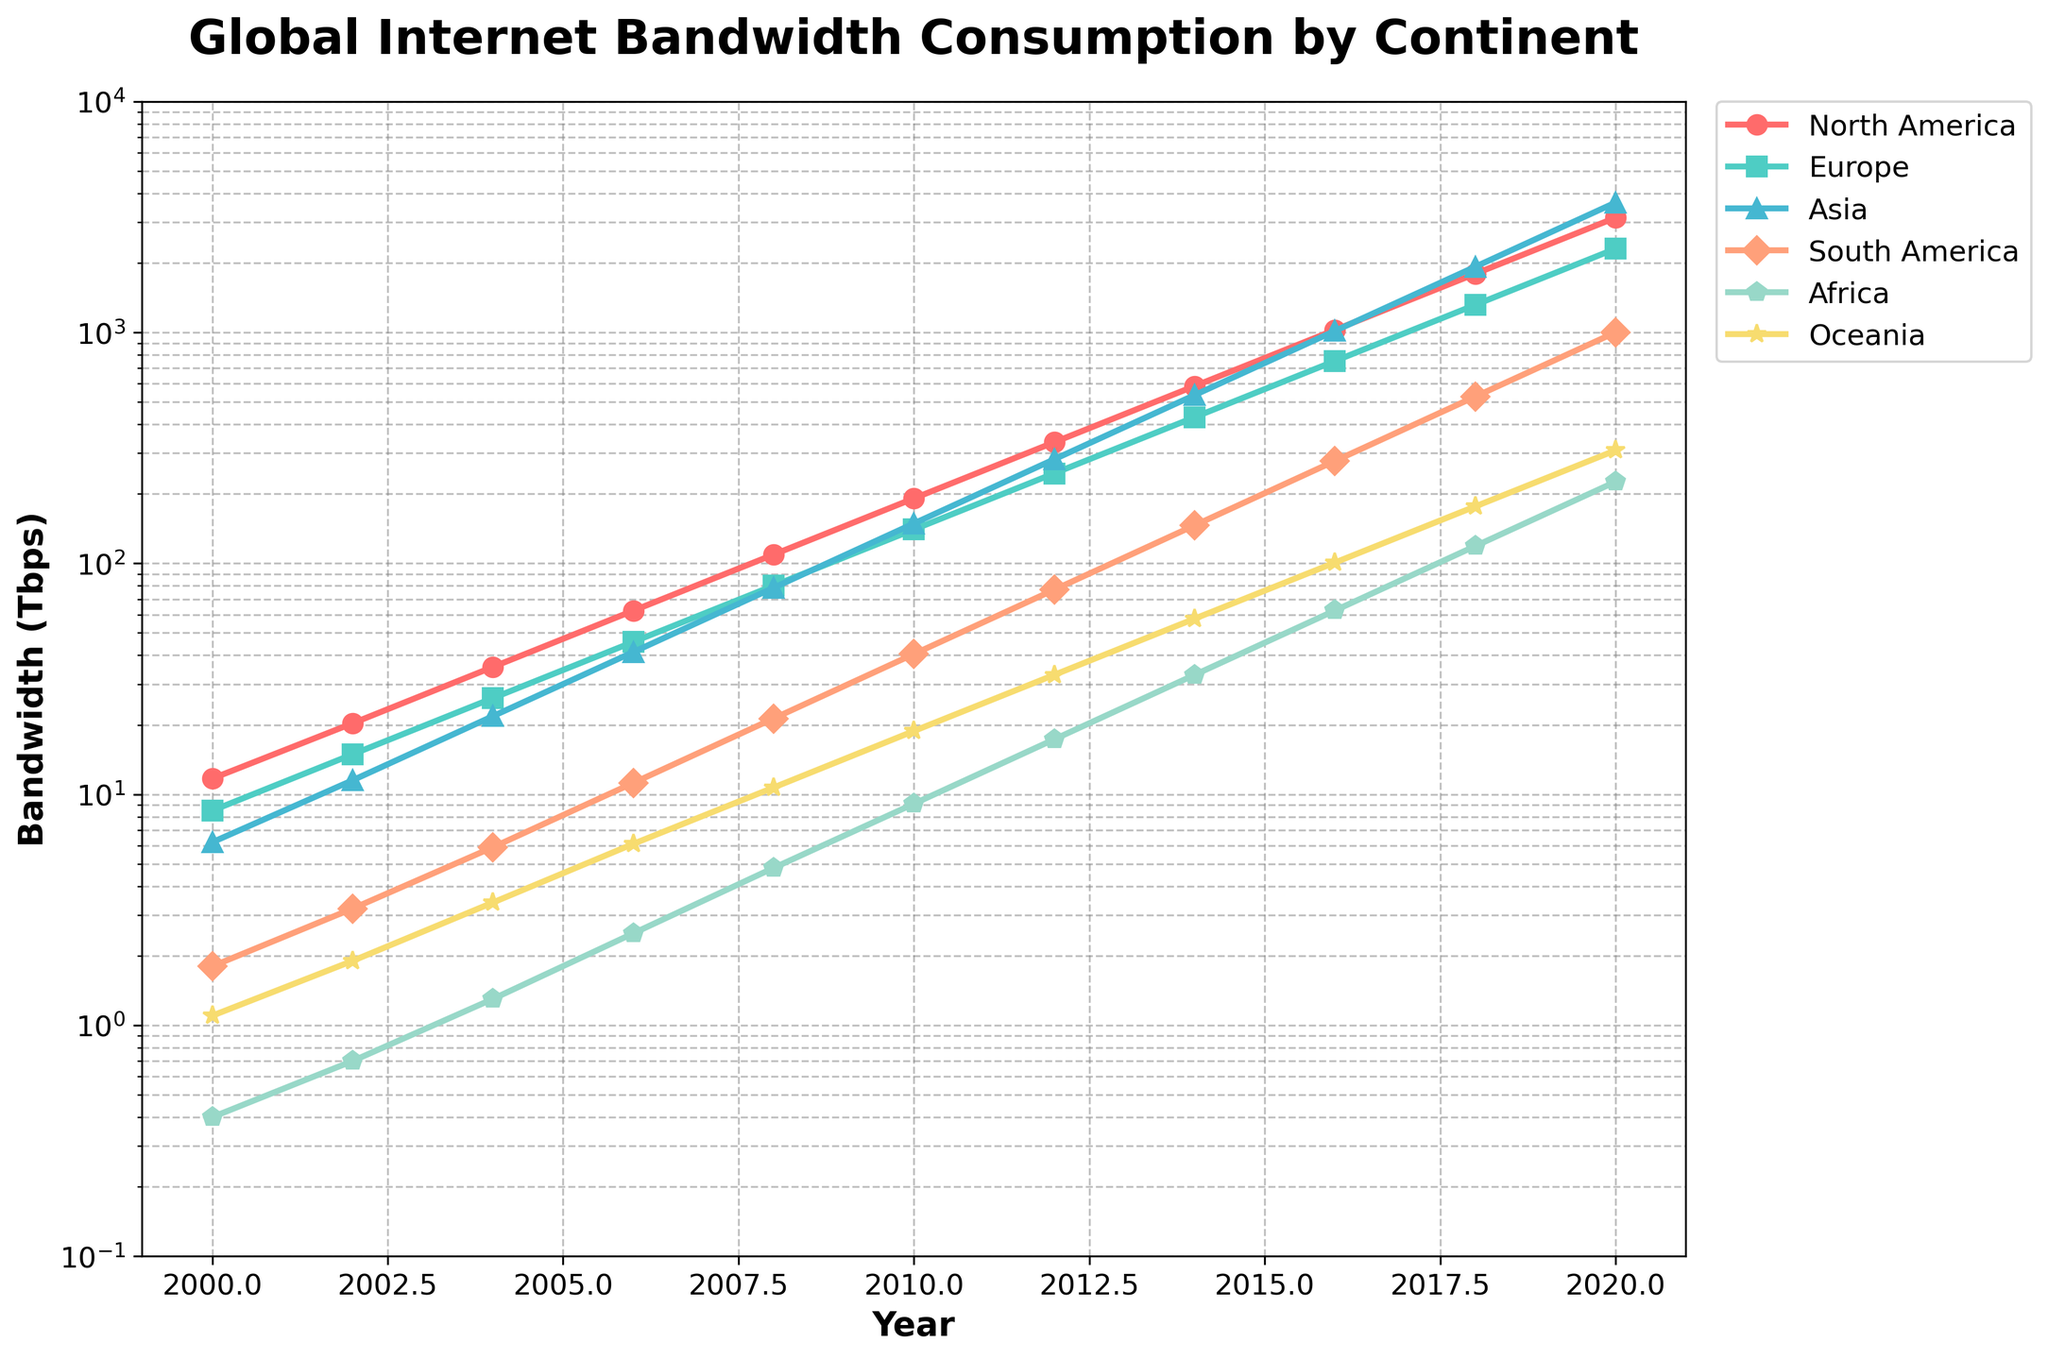What continent had the highest internet bandwidth consumption in 2020? To determine the continent with the highest internet bandwidth consumption in 2020, look at the endpoints of the line for each continent in 2020 on the x-axis. The highest point corresponds to Asia.
Answer: Asia How did the bandwidth consumption in Europe change from 2002 to 2008? Observe the value at Europe for the years 2002 and 2008. In 2002, it was 14.9 Tbps, and in 2008 it was 80.1 Tbps. The change is 80.1 - 14.9 = 65.2 Tbps.
Answer: Increased by 65.2 Tbps Which continent had the lowest bandwidth consumption in 2010, and what was the value? Examine the value for each continent in 2010. Africa has the lowest value at 9.1 Tbps.
Answer: Africa, 9.1 Tbps Compare the bandwidth growth rates between North America and Asia from 2000 to 2020. Which grew faster? For North America, the value goes from 11.7 Tbps to 3140.4 Tbps. For Asia, it goes from 6.2 Tbps to 3651.7 Tbps. Asia grew faster.
Answer: Asia What is the trend in Oceania's bandwidth consumption from 2006 to 2018? Look at the values for Oceania between 2006 and 2018. The values are 6.1 Tbps in 2006 and 176.4 Tbps in 2018, showing consistent growth.
Answer: Increasing trend What is the percentage increase in South America's bandwidth consumption from 2008 to 2018? First, find the values: South America had 21.3 Tbps in 2008 and 527.4 Tbps in 2018. The percentage increase is ((527.4 - 21.3) / 21.3) * 100% = 2376.06%.
Answer: 2376.06% What was the most significant increase in bandwidth consumption among all continents between two consecutive years? Check the largest differences between consecutive data points for all continents. North America increased by 1345.9 Tbps (1794.5 to 3140.4) between 2018 and 2020.
Answer: North America from 2018 to 2020 Describe the pattern of bandwidth consumption in Africa over the years. Africa's bandwidth starts very low at 0.4 Tbps in 2000 and shows exponential growth to 225.7 Tbps by 2020.
Answer: Exponential increase How does the bandwidth consumption in North America in 2000 compare to Africa in 2020? In 2000, North America had 11.7 Tbps, while Africa had 225.7 Tbps in 2020. Africa's 2020 consumption is much higher.
Answer: Africa in 2020 was much higher What visual attributes can you observe about the trend lines for North America and Europe? North America is represented with red and Europe with green. Both lines show a steep increase over time, but Asia surpasses both in 2018.
Answer: Red and green lines indicating steep increases 